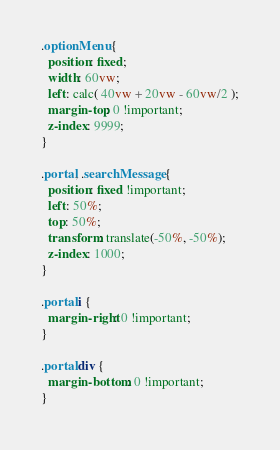<code> <loc_0><loc_0><loc_500><loc_500><_CSS_>.optionMenu {
  position: fixed;
  width: 60vw;
  left: calc( 40vw + 20vw - 60vw/2 );
  margin-top: 0 !important;
  z-index: 9999;
}

.portal, .searchMessage {
  position: fixed !important;
  left: 50%;
  top: 50%;
  transform: translate(-50%, -50%);
  z-index: 1000;
}

.portal i {
  margin-right: 0 !important;
}

.portal div {
  margin-bottom: 0 !important;
}
</code> 